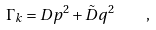<formula> <loc_0><loc_0><loc_500><loc_500>\Gamma _ { k } = D p ^ { 2 } + { \tilde { D } } q ^ { 2 } \quad ,</formula> 